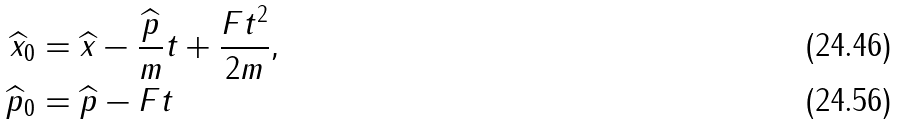<formula> <loc_0><loc_0><loc_500><loc_500>\widehat { x } _ { 0 } & = \widehat { x } - \frac { \widehat { p } } { m } t + \frac { F t ^ { 2 } } { 2 m } , \\ \widehat { p } _ { 0 } & = \widehat { p } - F t</formula> 